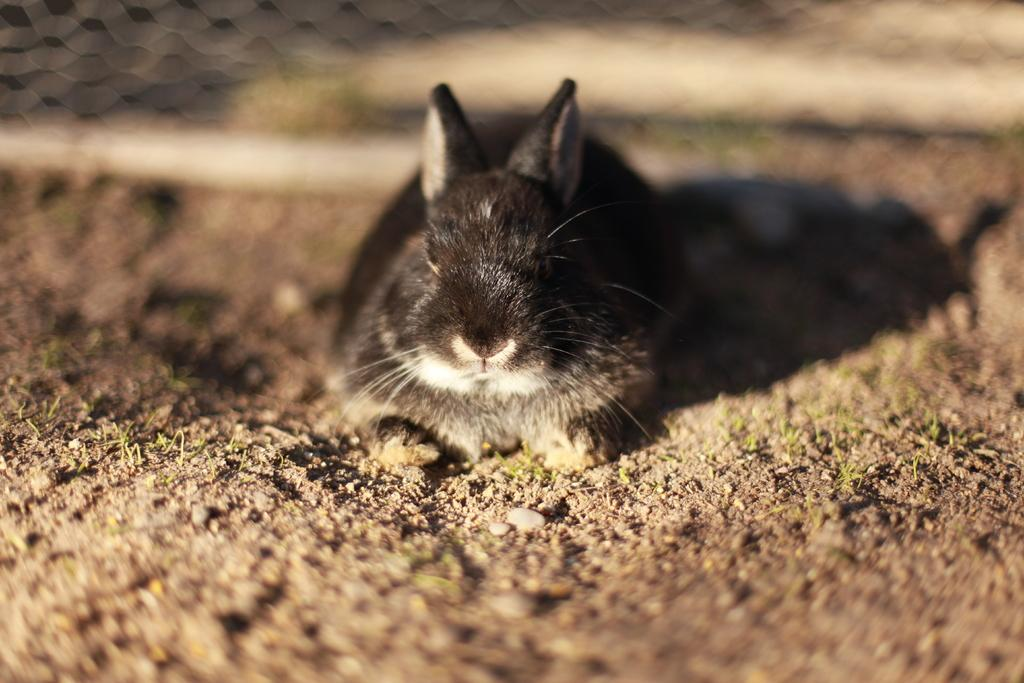What is the main subject of the image? There is an animal in the center of the image. What color is the animal in the image? The animal is in black and white color. Can you describe the background of the image? The background of the image is blurred. What type of income does the animal in the image generate? The image does not provide any information about the animal's income, as it is not relevant to the image's content. 